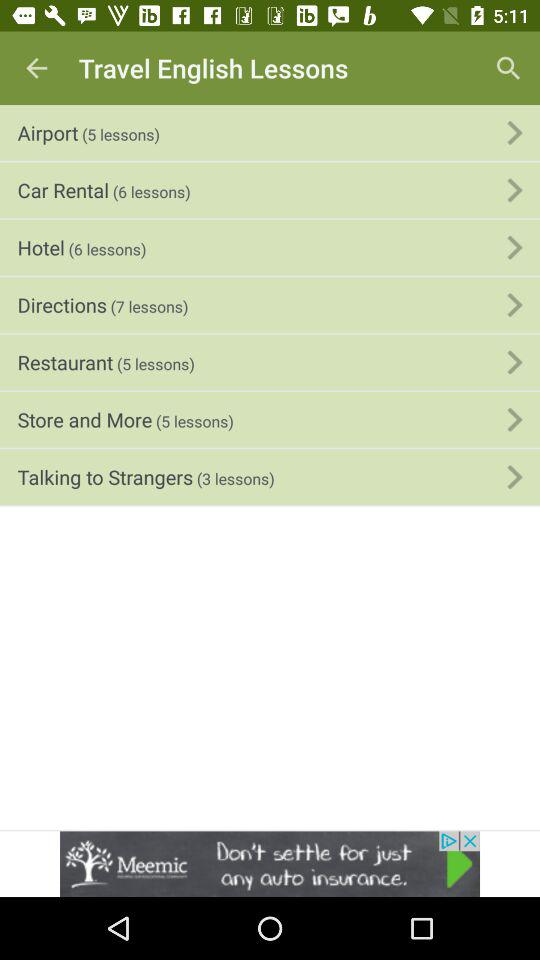How many lessons are in the Store and More section? 5 